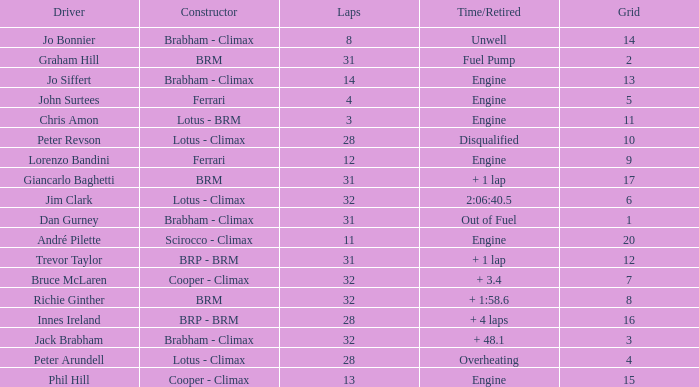What is the average grid for jack brabham going over 32 laps? None. 